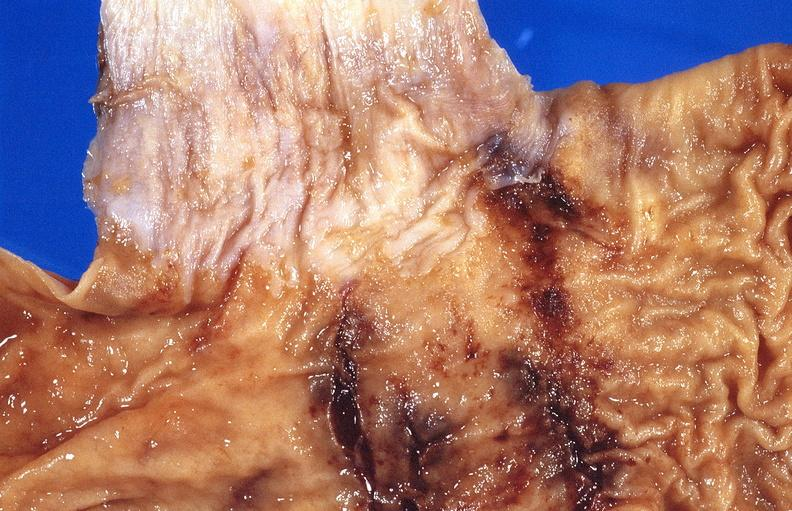does carcinomatosis endometrium primary show stomach, cushing ulcers?
Answer the question using a single word or phrase. No 